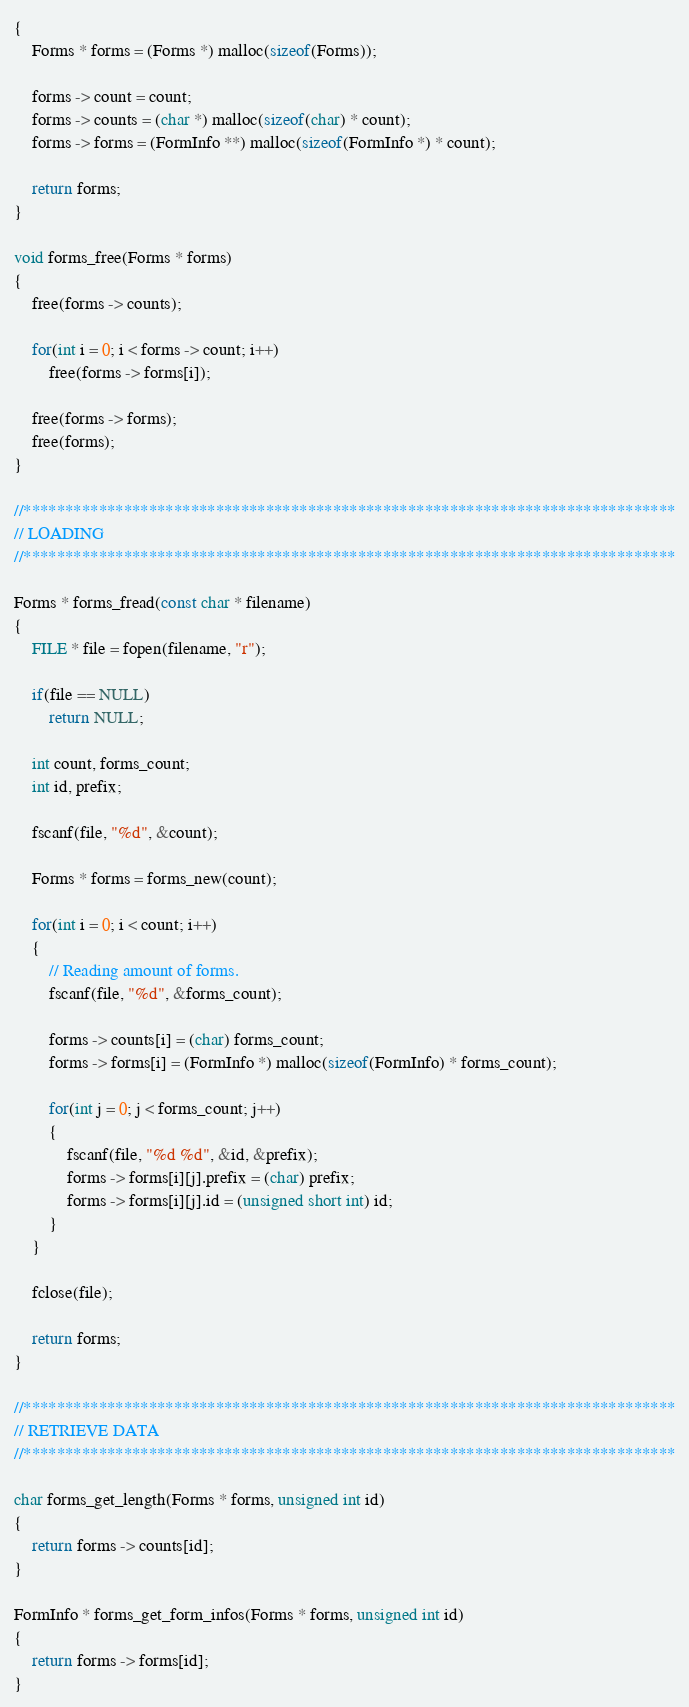<code> <loc_0><loc_0><loc_500><loc_500><_C++_>{
    Forms * forms = (Forms *) malloc(sizeof(Forms));

    forms -> count = count;
    forms -> counts = (char *) malloc(sizeof(char) * count);
    forms -> forms = (FormInfo **) malloc(sizeof(FormInfo *) * count);

    return forms;
}

void forms_free(Forms * forms)
{
    free(forms -> counts);

    for(int i = 0; i < forms -> count; i++)
        free(forms -> forms[i]);

    free(forms -> forms);
    free(forms);
}

//******************************************************************************
// LOADING
//******************************************************************************

Forms * forms_fread(const char * filename)
{
    FILE * file = fopen(filename, "r");

    if(file == NULL)
        return NULL;

    int count, forms_count;
    int id, prefix;

    fscanf(file, "%d", &count);

    Forms * forms = forms_new(count);

    for(int i = 0; i < count; i++)
    {
        // Reading amount of forms.
        fscanf(file, "%d", &forms_count);

        forms -> counts[i] = (char) forms_count;
        forms -> forms[i] = (FormInfo *) malloc(sizeof(FormInfo) * forms_count);

        for(int j = 0; j < forms_count; j++)
        {
            fscanf(file, "%d %d", &id, &prefix);
            forms -> forms[i][j].prefix = (char) prefix;
            forms -> forms[i][j].id = (unsigned short int) id;
        }
    }

    fclose(file);

    return forms;
}

//******************************************************************************
// RETRIEVE DATA
//******************************************************************************

char forms_get_length(Forms * forms, unsigned int id)
{
    return forms -> counts[id];
}

FormInfo * forms_get_form_infos(Forms * forms, unsigned int id)
{
    return forms -> forms[id];
}
</code> 